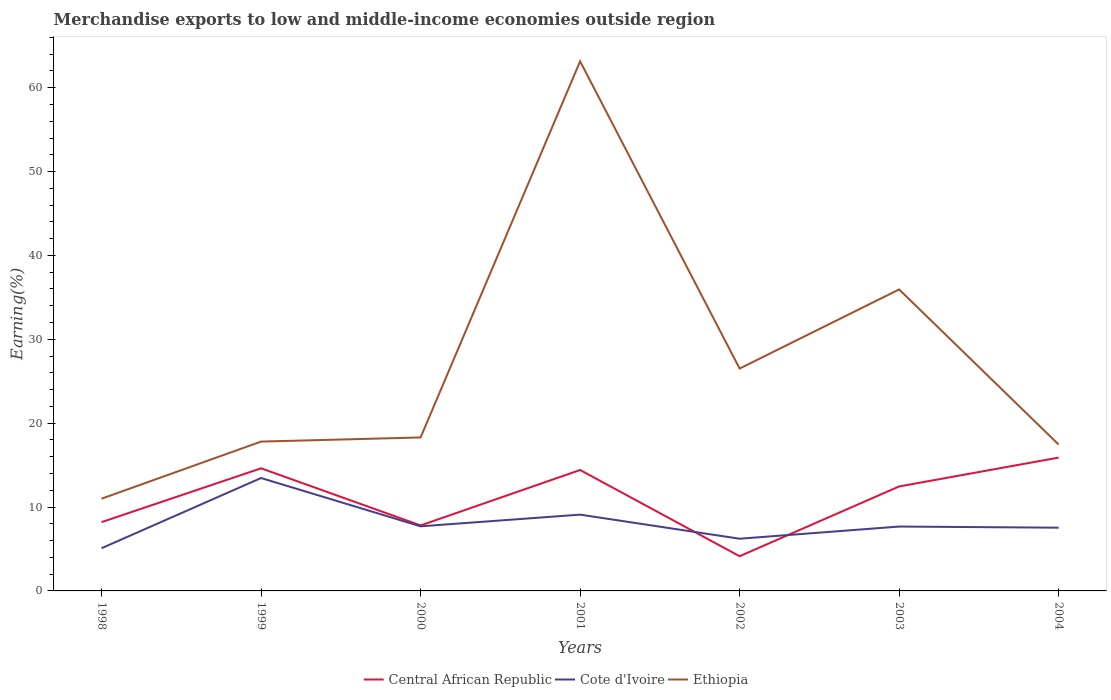How many different coloured lines are there?
Your answer should be compact. 3. Is the number of lines equal to the number of legend labels?
Provide a short and direct response. Yes. Across all years, what is the maximum percentage of amount earned from merchandise exports in Ethiopia?
Give a very brief answer. 11. In which year was the percentage of amount earned from merchandise exports in Central African Republic maximum?
Offer a terse response. 2002. What is the total percentage of amount earned from merchandise exports in Central African Republic in the graph?
Provide a short and direct response. -6.42. What is the difference between the highest and the second highest percentage of amount earned from merchandise exports in Central African Republic?
Ensure brevity in your answer.  11.76. How many lines are there?
Provide a short and direct response. 3. How many years are there in the graph?
Your answer should be very brief. 7. Where does the legend appear in the graph?
Provide a short and direct response. Bottom center. How many legend labels are there?
Offer a very short reply. 3. What is the title of the graph?
Offer a terse response. Merchandise exports to low and middle-income economies outside region. Does "Pacific island small states" appear as one of the legend labels in the graph?
Your answer should be very brief. No. What is the label or title of the Y-axis?
Provide a short and direct response. Earning(%). What is the Earning(%) of Central African Republic in 1998?
Provide a short and direct response. 8.2. What is the Earning(%) of Cote d'Ivoire in 1998?
Provide a succinct answer. 5.09. What is the Earning(%) of Ethiopia in 1998?
Your answer should be very brief. 11. What is the Earning(%) of Central African Republic in 1999?
Your answer should be very brief. 14.62. What is the Earning(%) in Cote d'Ivoire in 1999?
Make the answer very short. 13.46. What is the Earning(%) of Ethiopia in 1999?
Keep it short and to the point. 17.81. What is the Earning(%) of Central African Republic in 2000?
Offer a terse response. 7.81. What is the Earning(%) in Cote d'Ivoire in 2000?
Provide a succinct answer. 7.7. What is the Earning(%) of Ethiopia in 2000?
Offer a terse response. 18.3. What is the Earning(%) of Central African Republic in 2001?
Make the answer very short. 14.42. What is the Earning(%) in Cote d'Ivoire in 2001?
Your response must be concise. 9.1. What is the Earning(%) in Ethiopia in 2001?
Keep it short and to the point. 63.14. What is the Earning(%) of Central African Republic in 2002?
Offer a terse response. 4.14. What is the Earning(%) of Cote d'Ivoire in 2002?
Offer a very short reply. 6.22. What is the Earning(%) of Ethiopia in 2002?
Offer a terse response. 26.51. What is the Earning(%) in Central African Republic in 2003?
Your answer should be very brief. 12.46. What is the Earning(%) in Cote d'Ivoire in 2003?
Your answer should be very brief. 7.68. What is the Earning(%) in Ethiopia in 2003?
Offer a very short reply. 35.94. What is the Earning(%) of Central African Republic in 2004?
Offer a very short reply. 15.9. What is the Earning(%) in Cote d'Ivoire in 2004?
Give a very brief answer. 7.54. What is the Earning(%) of Ethiopia in 2004?
Your response must be concise. 17.45. Across all years, what is the maximum Earning(%) in Central African Republic?
Provide a short and direct response. 15.9. Across all years, what is the maximum Earning(%) of Cote d'Ivoire?
Give a very brief answer. 13.46. Across all years, what is the maximum Earning(%) in Ethiopia?
Offer a terse response. 63.14. Across all years, what is the minimum Earning(%) of Central African Republic?
Offer a very short reply. 4.14. Across all years, what is the minimum Earning(%) in Cote d'Ivoire?
Give a very brief answer. 5.09. Across all years, what is the minimum Earning(%) of Ethiopia?
Provide a succinct answer. 11. What is the total Earning(%) of Central African Republic in the graph?
Give a very brief answer. 77.54. What is the total Earning(%) of Cote d'Ivoire in the graph?
Provide a short and direct response. 56.79. What is the total Earning(%) in Ethiopia in the graph?
Offer a terse response. 190.15. What is the difference between the Earning(%) of Central African Republic in 1998 and that in 1999?
Offer a very short reply. -6.42. What is the difference between the Earning(%) in Cote d'Ivoire in 1998 and that in 1999?
Provide a succinct answer. -8.37. What is the difference between the Earning(%) of Ethiopia in 1998 and that in 1999?
Offer a very short reply. -6.81. What is the difference between the Earning(%) of Central African Republic in 1998 and that in 2000?
Ensure brevity in your answer.  0.39. What is the difference between the Earning(%) in Cote d'Ivoire in 1998 and that in 2000?
Give a very brief answer. -2.61. What is the difference between the Earning(%) of Ethiopia in 1998 and that in 2000?
Provide a succinct answer. -7.3. What is the difference between the Earning(%) in Central African Republic in 1998 and that in 2001?
Your answer should be very brief. -6.21. What is the difference between the Earning(%) in Cote d'Ivoire in 1998 and that in 2001?
Your response must be concise. -4. What is the difference between the Earning(%) of Ethiopia in 1998 and that in 2001?
Give a very brief answer. -52.15. What is the difference between the Earning(%) of Central African Republic in 1998 and that in 2002?
Offer a terse response. 4.07. What is the difference between the Earning(%) in Cote d'Ivoire in 1998 and that in 2002?
Make the answer very short. -1.13. What is the difference between the Earning(%) of Ethiopia in 1998 and that in 2002?
Provide a short and direct response. -15.51. What is the difference between the Earning(%) in Central African Republic in 1998 and that in 2003?
Your answer should be very brief. -4.25. What is the difference between the Earning(%) in Cote d'Ivoire in 1998 and that in 2003?
Your answer should be very brief. -2.58. What is the difference between the Earning(%) of Ethiopia in 1998 and that in 2003?
Offer a very short reply. -24.95. What is the difference between the Earning(%) of Central African Republic in 1998 and that in 2004?
Keep it short and to the point. -7.69. What is the difference between the Earning(%) in Cote d'Ivoire in 1998 and that in 2004?
Provide a succinct answer. -2.45. What is the difference between the Earning(%) in Ethiopia in 1998 and that in 2004?
Make the answer very short. -6.46. What is the difference between the Earning(%) in Central African Republic in 1999 and that in 2000?
Make the answer very short. 6.81. What is the difference between the Earning(%) of Cote d'Ivoire in 1999 and that in 2000?
Your response must be concise. 5.76. What is the difference between the Earning(%) of Ethiopia in 1999 and that in 2000?
Make the answer very short. -0.49. What is the difference between the Earning(%) of Central African Republic in 1999 and that in 2001?
Offer a terse response. 0.2. What is the difference between the Earning(%) of Cote d'Ivoire in 1999 and that in 2001?
Offer a terse response. 4.36. What is the difference between the Earning(%) of Ethiopia in 1999 and that in 2001?
Give a very brief answer. -45.34. What is the difference between the Earning(%) of Central African Republic in 1999 and that in 2002?
Your answer should be very brief. 10.48. What is the difference between the Earning(%) in Cote d'Ivoire in 1999 and that in 2002?
Provide a succinct answer. 7.24. What is the difference between the Earning(%) of Ethiopia in 1999 and that in 2002?
Make the answer very short. -8.7. What is the difference between the Earning(%) in Central African Republic in 1999 and that in 2003?
Provide a succinct answer. 2.16. What is the difference between the Earning(%) in Cote d'Ivoire in 1999 and that in 2003?
Your response must be concise. 5.79. What is the difference between the Earning(%) of Ethiopia in 1999 and that in 2003?
Ensure brevity in your answer.  -18.14. What is the difference between the Earning(%) in Central African Republic in 1999 and that in 2004?
Offer a terse response. -1.28. What is the difference between the Earning(%) of Cote d'Ivoire in 1999 and that in 2004?
Provide a succinct answer. 5.92. What is the difference between the Earning(%) of Ethiopia in 1999 and that in 2004?
Make the answer very short. 0.35. What is the difference between the Earning(%) of Central African Republic in 2000 and that in 2001?
Your answer should be compact. -6.61. What is the difference between the Earning(%) in Cote d'Ivoire in 2000 and that in 2001?
Provide a succinct answer. -1.39. What is the difference between the Earning(%) of Ethiopia in 2000 and that in 2001?
Provide a short and direct response. -44.85. What is the difference between the Earning(%) of Central African Republic in 2000 and that in 2002?
Ensure brevity in your answer.  3.67. What is the difference between the Earning(%) in Cote d'Ivoire in 2000 and that in 2002?
Ensure brevity in your answer.  1.48. What is the difference between the Earning(%) of Ethiopia in 2000 and that in 2002?
Your response must be concise. -8.21. What is the difference between the Earning(%) in Central African Republic in 2000 and that in 2003?
Offer a terse response. -4.65. What is the difference between the Earning(%) of Cote d'Ivoire in 2000 and that in 2003?
Your answer should be compact. 0.03. What is the difference between the Earning(%) of Ethiopia in 2000 and that in 2003?
Offer a terse response. -17.65. What is the difference between the Earning(%) of Central African Republic in 2000 and that in 2004?
Give a very brief answer. -8.09. What is the difference between the Earning(%) in Cote d'Ivoire in 2000 and that in 2004?
Offer a terse response. 0.16. What is the difference between the Earning(%) in Ethiopia in 2000 and that in 2004?
Keep it short and to the point. 0.85. What is the difference between the Earning(%) in Central African Republic in 2001 and that in 2002?
Your answer should be very brief. 10.28. What is the difference between the Earning(%) of Cote d'Ivoire in 2001 and that in 2002?
Your answer should be compact. 2.87. What is the difference between the Earning(%) in Ethiopia in 2001 and that in 2002?
Keep it short and to the point. 36.63. What is the difference between the Earning(%) of Central African Republic in 2001 and that in 2003?
Your response must be concise. 1.96. What is the difference between the Earning(%) of Cote d'Ivoire in 2001 and that in 2003?
Your response must be concise. 1.42. What is the difference between the Earning(%) of Ethiopia in 2001 and that in 2003?
Give a very brief answer. 27.2. What is the difference between the Earning(%) of Central African Republic in 2001 and that in 2004?
Your response must be concise. -1.48. What is the difference between the Earning(%) in Cote d'Ivoire in 2001 and that in 2004?
Your answer should be very brief. 1.56. What is the difference between the Earning(%) of Ethiopia in 2001 and that in 2004?
Keep it short and to the point. 45.69. What is the difference between the Earning(%) in Central African Republic in 2002 and that in 2003?
Your answer should be compact. -8.32. What is the difference between the Earning(%) in Cote d'Ivoire in 2002 and that in 2003?
Ensure brevity in your answer.  -1.45. What is the difference between the Earning(%) in Ethiopia in 2002 and that in 2003?
Your response must be concise. -9.43. What is the difference between the Earning(%) in Central African Republic in 2002 and that in 2004?
Offer a very short reply. -11.76. What is the difference between the Earning(%) of Cote d'Ivoire in 2002 and that in 2004?
Ensure brevity in your answer.  -1.32. What is the difference between the Earning(%) in Ethiopia in 2002 and that in 2004?
Keep it short and to the point. 9.06. What is the difference between the Earning(%) of Central African Republic in 2003 and that in 2004?
Provide a succinct answer. -3.44. What is the difference between the Earning(%) in Cote d'Ivoire in 2003 and that in 2004?
Make the answer very short. 0.14. What is the difference between the Earning(%) of Ethiopia in 2003 and that in 2004?
Your answer should be very brief. 18.49. What is the difference between the Earning(%) in Central African Republic in 1998 and the Earning(%) in Cote d'Ivoire in 1999?
Your answer should be very brief. -5.26. What is the difference between the Earning(%) of Central African Republic in 1998 and the Earning(%) of Ethiopia in 1999?
Provide a short and direct response. -9.6. What is the difference between the Earning(%) of Cote d'Ivoire in 1998 and the Earning(%) of Ethiopia in 1999?
Your answer should be compact. -12.71. What is the difference between the Earning(%) of Central African Republic in 1998 and the Earning(%) of Cote d'Ivoire in 2000?
Your response must be concise. 0.5. What is the difference between the Earning(%) in Central African Republic in 1998 and the Earning(%) in Ethiopia in 2000?
Provide a succinct answer. -10.1. What is the difference between the Earning(%) in Cote d'Ivoire in 1998 and the Earning(%) in Ethiopia in 2000?
Provide a short and direct response. -13.21. What is the difference between the Earning(%) in Central African Republic in 1998 and the Earning(%) in Cote d'Ivoire in 2001?
Provide a succinct answer. -0.89. What is the difference between the Earning(%) of Central African Republic in 1998 and the Earning(%) of Ethiopia in 2001?
Your response must be concise. -54.94. What is the difference between the Earning(%) of Cote d'Ivoire in 1998 and the Earning(%) of Ethiopia in 2001?
Ensure brevity in your answer.  -58.05. What is the difference between the Earning(%) in Central African Republic in 1998 and the Earning(%) in Cote d'Ivoire in 2002?
Your response must be concise. 1.98. What is the difference between the Earning(%) of Central African Republic in 1998 and the Earning(%) of Ethiopia in 2002?
Keep it short and to the point. -18.31. What is the difference between the Earning(%) in Cote d'Ivoire in 1998 and the Earning(%) in Ethiopia in 2002?
Ensure brevity in your answer.  -21.42. What is the difference between the Earning(%) in Central African Republic in 1998 and the Earning(%) in Cote d'Ivoire in 2003?
Make the answer very short. 0.53. What is the difference between the Earning(%) of Central African Republic in 1998 and the Earning(%) of Ethiopia in 2003?
Your response must be concise. -27.74. What is the difference between the Earning(%) of Cote d'Ivoire in 1998 and the Earning(%) of Ethiopia in 2003?
Your answer should be compact. -30.85. What is the difference between the Earning(%) in Central African Republic in 1998 and the Earning(%) in Cote d'Ivoire in 2004?
Keep it short and to the point. 0.66. What is the difference between the Earning(%) of Central African Republic in 1998 and the Earning(%) of Ethiopia in 2004?
Offer a very short reply. -9.25. What is the difference between the Earning(%) of Cote d'Ivoire in 1998 and the Earning(%) of Ethiopia in 2004?
Give a very brief answer. -12.36. What is the difference between the Earning(%) in Central African Republic in 1999 and the Earning(%) in Cote d'Ivoire in 2000?
Your answer should be very brief. 6.92. What is the difference between the Earning(%) in Central African Republic in 1999 and the Earning(%) in Ethiopia in 2000?
Ensure brevity in your answer.  -3.68. What is the difference between the Earning(%) of Cote d'Ivoire in 1999 and the Earning(%) of Ethiopia in 2000?
Offer a very short reply. -4.84. What is the difference between the Earning(%) in Central African Republic in 1999 and the Earning(%) in Cote d'Ivoire in 2001?
Make the answer very short. 5.52. What is the difference between the Earning(%) of Central African Republic in 1999 and the Earning(%) of Ethiopia in 2001?
Ensure brevity in your answer.  -48.52. What is the difference between the Earning(%) of Cote d'Ivoire in 1999 and the Earning(%) of Ethiopia in 2001?
Offer a very short reply. -49.68. What is the difference between the Earning(%) of Central African Republic in 1999 and the Earning(%) of Cote d'Ivoire in 2002?
Keep it short and to the point. 8.4. What is the difference between the Earning(%) in Central African Republic in 1999 and the Earning(%) in Ethiopia in 2002?
Your answer should be very brief. -11.89. What is the difference between the Earning(%) of Cote d'Ivoire in 1999 and the Earning(%) of Ethiopia in 2002?
Ensure brevity in your answer.  -13.05. What is the difference between the Earning(%) in Central African Republic in 1999 and the Earning(%) in Cote d'Ivoire in 2003?
Offer a very short reply. 6.94. What is the difference between the Earning(%) of Central African Republic in 1999 and the Earning(%) of Ethiopia in 2003?
Provide a short and direct response. -21.33. What is the difference between the Earning(%) of Cote d'Ivoire in 1999 and the Earning(%) of Ethiopia in 2003?
Your answer should be very brief. -22.48. What is the difference between the Earning(%) of Central African Republic in 1999 and the Earning(%) of Cote d'Ivoire in 2004?
Your response must be concise. 7.08. What is the difference between the Earning(%) in Central African Republic in 1999 and the Earning(%) in Ethiopia in 2004?
Offer a very short reply. -2.83. What is the difference between the Earning(%) of Cote d'Ivoire in 1999 and the Earning(%) of Ethiopia in 2004?
Your answer should be compact. -3.99. What is the difference between the Earning(%) of Central African Republic in 2000 and the Earning(%) of Cote d'Ivoire in 2001?
Offer a very short reply. -1.29. What is the difference between the Earning(%) in Central African Republic in 2000 and the Earning(%) in Ethiopia in 2001?
Provide a short and direct response. -55.34. What is the difference between the Earning(%) of Cote d'Ivoire in 2000 and the Earning(%) of Ethiopia in 2001?
Ensure brevity in your answer.  -55.44. What is the difference between the Earning(%) in Central African Republic in 2000 and the Earning(%) in Cote d'Ivoire in 2002?
Provide a short and direct response. 1.59. What is the difference between the Earning(%) of Central African Republic in 2000 and the Earning(%) of Ethiopia in 2002?
Provide a short and direct response. -18.7. What is the difference between the Earning(%) in Cote d'Ivoire in 2000 and the Earning(%) in Ethiopia in 2002?
Provide a short and direct response. -18.81. What is the difference between the Earning(%) of Central African Republic in 2000 and the Earning(%) of Cote d'Ivoire in 2003?
Make the answer very short. 0.13. What is the difference between the Earning(%) in Central African Republic in 2000 and the Earning(%) in Ethiopia in 2003?
Your answer should be very brief. -28.14. What is the difference between the Earning(%) in Cote d'Ivoire in 2000 and the Earning(%) in Ethiopia in 2003?
Your answer should be very brief. -28.24. What is the difference between the Earning(%) in Central African Republic in 2000 and the Earning(%) in Cote d'Ivoire in 2004?
Offer a very short reply. 0.27. What is the difference between the Earning(%) of Central African Republic in 2000 and the Earning(%) of Ethiopia in 2004?
Your answer should be compact. -9.64. What is the difference between the Earning(%) in Cote d'Ivoire in 2000 and the Earning(%) in Ethiopia in 2004?
Your answer should be very brief. -9.75. What is the difference between the Earning(%) of Central African Republic in 2001 and the Earning(%) of Cote d'Ivoire in 2002?
Your response must be concise. 8.19. What is the difference between the Earning(%) in Central African Republic in 2001 and the Earning(%) in Ethiopia in 2002?
Your answer should be compact. -12.09. What is the difference between the Earning(%) in Cote d'Ivoire in 2001 and the Earning(%) in Ethiopia in 2002?
Provide a short and direct response. -17.41. What is the difference between the Earning(%) of Central African Republic in 2001 and the Earning(%) of Cote d'Ivoire in 2003?
Ensure brevity in your answer.  6.74. What is the difference between the Earning(%) of Central African Republic in 2001 and the Earning(%) of Ethiopia in 2003?
Give a very brief answer. -21.53. What is the difference between the Earning(%) in Cote d'Ivoire in 2001 and the Earning(%) in Ethiopia in 2003?
Offer a terse response. -26.85. What is the difference between the Earning(%) in Central African Republic in 2001 and the Earning(%) in Cote d'Ivoire in 2004?
Ensure brevity in your answer.  6.88. What is the difference between the Earning(%) of Central African Republic in 2001 and the Earning(%) of Ethiopia in 2004?
Give a very brief answer. -3.04. What is the difference between the Earning(%) in Cote d'Ivoire in 2001 and the Earning(%) in Ethiopia in 2004?
Provide a short and direct response. -8.36. What is the difference between the Earning(%) in Central African Republic in 2002 and the Earning(%) in Cote d'Ivoire in 2003?
Keep it short and to the point. -3.54. What is the difference between the Earning(%) of Central African Republic in 2002 and the Earning(%) of Ethiopia in 2003?
Keep it short and to the point. -31.81. What is the difference between the Earning(%) of Cote d'Ivoire in 2002 and the Earning(%) of Ethiopia in 2003?
Provide a succinct answer. -29.72. What is the difference between the Earning(%) of Central African Republic in 2002 and the Earning(%) of Cote d'Ivoire in 2004?
Provide a short and direct response. -3.4. What is the difference between the Earning(%) in Central African Republic in 2002 and the Earning(%) in Ethiopia in 2004?
Offer a very short reply. -13.31. What is the difference between the Earning(%) in Cote d'Ivoire in 2002 and the Earning(%) in Ethiopia in 2004?
Your answer should be very brief. -11.23. What is the difference between the Earning(%) in Central African Republic in 2003 and the Earning(%) in Cote d'Ivoire in 2004?
Offer a terse response. 4.92. What is the difference between the Earning(%) in Central African Republic in 2003 and the Earning(%) in Ethiopia in 2004?
Your answer should be very brief. -5. What is the difference between the Earning(%) in Cote d'Ivoire in 2003 and the Earning(%) in Ethiopia in 2004?
Provide a succinct answer. -9.78. What is the average Earning(%) of Central African Republic per year?
Keep it short and to the point. 11.08. What is the average Earning(%) of Cote d'Ivoire per year?
Provide a short and direct response. 8.11. What is the average Earning(%) in Ethiopia per year?
Give a very brief answer. 27.16. In the year 1998, what is the difference between the Earning(%) in Central African Republic and Earning(%) in Cote d'Ivoire?
Offer a very short reply. 3.11. In the year 1998, what is the difference between the Earning(%) in Central African Republic and Earning(%) in Ethiopia?
Keep it short and to the point. -2.79. In the year 1998, what is the difference between the Earning(%) in Cote d'Ivoire and Earning(%) in Ethiopia?
Offer a very short reply. -5.9. In the year 1999, what is the difference between the Earning(%) of Central African Republic and Earning(%) of Cote d'Ivoire?
Your answer should be compact. 1.16. In the year 1999, what is the difference between the Earning(%) of Central African Republic and Earning(%) of Ethiopia?
Your answer should be compact. -3.19. In the year 1999, what is the difference between the Earning(%) of Cote d'Ivoire and Earning(%) of Ethiopia?
Ensure brevity in your answer.  -4.35. In the year 2000, what is the difference between the Earning(%) of Central African Republic and Earning(%) of Cote d'Ivoire?
Make the answer very short. 0.11. In the year 2000, what is the difference between the Earning(%) of Central African Republic and Earning(%) of Ethiopia?
Your answer should be compact. -10.49. In the year 2000, what is the difference between the Earning(%) of Cote d'Ivoire and Earning(%) of Ethiopia?
Provide a succinct answer. -10.6. In the year 2001, what is the difference between the Earning(%) in Central African Republic and Earning(%) in Cote d'Ivoire?
Make the answer very short. 5.32. In the year 2001, what is the difference between the Earning(%) in Central African Republic and Earning(%) in Ethiopia?
Provide a succinct answer. -48.73. In the year 2001, what is the difference between the Earning(%) of Cote d'Ivoire and Earning(%) of Ethiopia?
Ensure brevity in your answer.  -54.05. In the year 2002, what is the difference between the Earning(%) in Central African Republic and Earning(%) in Cote d'Ivoire?
Make the answer very short. -2.09. In the year 2002, what is the difference between the Earning(%) of Central African Republic and Earning(%) of Ethiopia?
Your response must be concise. -22.37. In the year 2002, what is the difference between the Earning(%) of Cote d'Ivoire and Earning(%) of Ethiopia?
Your response must be concise. -20.29. In the year 2003, what is the difference between the Earning(%) of Central African Republic and Earning(%) of Cote d'Ivoire?
Provide a short and direct response. 4.78. In the year 2003, what is the difference between the Earning(%) in Central African Republic and Earning(%) in Ethiopia?
Your answer should be very brief. -23.49. In the year 2003, what is the difference between the Earning(%) in Cote d'Ivoire and Earning(%) in Ethiopia?
Your answer should be compact. -28.27. In the year 2004, what is the difference between the Earning(%) in Central African Republic and Earning(%) in Cote d'Ivoire?
Your answer should be compact. 8.36. In the year 2004, what is the difference between the Earning(%) of Central African Republic and Earning(%) of Ethiopia?
Provide a short and direct response. -1.56. In the year 2004, what is the difference between the Earning(%) in Cote d'Ivoire and Earning(%) in Ethiopia?
Ensure brevity in your answer.  -9.91. What is the ratio of the Earning(%) in Central African Republic in 1998 to that in 1999?
Keep it short and to the point. 0.56. What is the ratio of the Earning(%) of Cote d'Ivoire in 1998 to that in 1999?
Your answer should be compact. 0.38. What is the ratio of the Earning(%) of Ethiopia in 1998 to that in 1999?
Offer a very short reply. 0.62. What is the ratio of the Earning(%) in Central African Republic in 1998 to that in 2000?
Offer a terse response. 1.05. What is the ratio of the Earning(%) of Cote d'Ivoire in 1998 to that in 2000?
Provide a short and direct response. 0.66. What is the ratio of the Earning(%) in Ethiopia in 1998 to that in 2000?
Give a very brief answer. 0.6. What is the ratio of the Earning(%) in Central African Republic in 1998 to that in 2001?
Your response must be concise. 0.57. What is the ratio of the Earning(%) of Cote d'Ivoire in 1998 to that in 2001?
Keep it short and to the point. 0.56. What is the ratio of the Earning(%) of Ethiopia in 1998 to that in 2001?
Your answer should be compact. 0.17. What is the ratio of the Earning(%) in Central African Republic in 1998 to that in 2002?
Give a very brief answer. 1.98. What is the ratio of the Earning(%) in Cote d'Ivoire in 1998 to that in 2002?
Provide a succinct answer. 0.82. What is the ratio of the Earning(%) in Ethiopia in 1998 to that in 2002?
Your response must be concise. 0.41. What is the ratio of the Earning(%) of Central African Republic in 1998 to that in 2003?
Give a very brief answer. 0.66. What is the ratio of the Earning(%) in Cote d'Ivoire in 1998 to that in 2003?
Provide a short and direct response. 0.66. What is the ratio of the Earning(%) of Ethiopia in 1998 to that in 2003?
Your answer should be compact. 0.31. What is the ratio of the Earning(%) in Central African Republic in 1998 to that in 2004?
Offer a terse response. 0.52. What is the ratio of the Earning(%) in Cote d'Ivoire in 1998 to that in 2004?
Your response must be concise. 0.68. What is the ratio of the Earning(%) of Ethiopia in 1998 to that in 2004?
Give a very brief answer. 0.63. What is the ratio of the Earning(%) in Central African Republic in 1999 to that in 2000?
Make the answer very short. 1.87. What is the ratio of the Earning(%) in Cote d'Ivoire in 1999 to that in 2000?
Your answer should be compact. 1.75. What is the ratio of the Earning(%) of Ethiopia in 1999 to that in 2000?
Your answer should be very brief. 0.97. What is the ratio of the Earning(%) in Cote d'Ivoire in 1999 to that in 2001?
Provide a succinct answer. 1.48. What is the ratio of the Earning(%) of Ethiopia in 1999 to that in 2001?
Your answer should be very brief. 0.28. What is the ratio of the Earning(%) in Central African Republic in 1999 to that in 2002?
Your answer should be compact. 3.53. What is the ratio of the Earning(%) in Cote d'Ivoire in 1999 to that in 2002?
Provide a short and direct response. 2.16. What is the ratio of the Earning(%) in Ethiopia in 1999 to that in 2002?
Keep it short and to the point. 0.67. What is the ratio of the Earning(%) in Central African Republic in 1999 to that in 2003?
Offer a terse response. 1.17. What is the ratio of the Earning(%) in Cote d'Ivoire in 1999 to that in 2003?
Offer a terse response. 1.75. What is the ratio of the Earning(%) in Ethiopia in 1999 to that in 2003?
Make the answer very short. 0.5. What is the ratio of the Earning(%) in Central African Republic in 1999 to that in 2004?
Provide a succinct answer. 0.92. What is the ratio of the Earning(%) of Cote d'Ivoire in 1999 to that in 2004?
Offer a terse response. 1.79. What is the ratio of the Earning(%) in Ethiopia in 1999 to that in 2004?
Your answer should be very brief. 1.02. What is the ratio of the Earning(%) of Central African Republic in 2000 to that in 2001?
Ensure brevity in your answer.  0.54. What is the ratio of the Earning(%) of Cote d'Ivoire in 2000 to that in 2001?
Your answer should be very brief. 0.85. What is the ratio of the Earning(%) in Ethiopia in 2000 to that in 2001?
Provide a short and direct response. 0.29. What is the ratio of the Earning(%) in Central African Republic in 2000 to that in 2002?
Your answer should be very brief. 1.89. What is the ratio of the Earning(%) in Cote d'Ivoire in 2000 to that in 2002?
Ensure brevity in your answer.  1.24. What is the ratio of the Earning(%) in Ethiopia in 2000 to that in 2002?
Offer a terse response. 0.69. What is the ratio of the Earning(%) of Central African Republic in 2000 to that in 2003?
Offer a very short reply. 0.63. What is the ratio of the Earning(%) in Cote d'Ivoire in 2000 to that in 2003?
Your answer should be compact. 1. What is the ratio of the Earning(%) of Ethiopia in 2000 to that in 2003?
Keep it short and to the point. 0.51. What is the ratio of the Earning(%) in Central African Republic in 2000 to that in 2004?
Ensure brevity in your answer.  0.49. What is the ratio of the Earning(%) in Cote d'Ivoire in 2000 to that in 2004?
Provide a succinct answer. 1.02. What is the ratio of the Earning(%) of Ethiopia in 2000 to that in 2004?
Your response must be concise. 1.05. What is the ratio of the Earning(%) in Central African Republic in 2001 to that in 2002?
Your answer should be compact. 3.48. What is the ratio of the Earning(%) in Cote d'Ivoire in 2001 to that in 2002?
Provide a short and direct response. 1.46. What is the ratio of the Earning(%) in Ethiopia in 2001 to that in 2002?
Provide a succinct answer. 2.38. What is the ratio of the Earning(%) in Central African Republic in 2001 to that in 2003?
Ensure brevity in your answer.  1.16. What is the ratio of the Earning(%) in Cote d'Ivoire in 2001 to that in 2003?
Give a very brief answer. 1.19. What is the ratio of the Earning(%) of Ethiopia in 2001 to that in 2003?
Offer a very short reply. 1.76. What is the ratio of the Earning(%) in Central African Republic in 2001 to that in 2004?
Your answer should be compact. 0.91. What is the ratio of the Earning(%) of Cote d'Ivoire in 2001 to that in 2004?
Make the answer very short. 1.21. What is the ratio of the Earning(%) in Ethiopia in 2001 to that in 2004?
Provide a succinct answer. 3.62. What is the ratio of the Earning(%) in Central African Republic in 2002 to that in 2003?
Keep it short and to the point. 0.33. What is the ratio of the Earning(%) in Cote d'Ivoire in 2002 to that in 2003?
Offer a very short reply. 0.81. What is the ratio of the Earning(%) in Ethiopia in 2002 to that in 2003?
Your answer should be compact. 0.74. What is the ratio of the Earning(%) in Central African Republic in 2002 to that in 2004?
Offer a very short reply. 0.26. What is the ratio of the Earning(%) in Cote d'Ivoire in 2002 to that in 2004?
Your answer should be compact. 0.83. What is the ratio of the Earning(%) in Ethiopia in 2002 to that in 2004?
Offer a very short reply. 1.52. What is the ratio of the Earning(%) of Central African Republic in 2003 to that in 2004?
Your answer should be compact. 0.78. What is the ratio of the Earning(%) in Cote d'Ivoire in 2003 to that in 2004?
Provide a short and direct response. 1.02. What is the ratio of the Earning(%) of Ethiopia in 2003 to that in 2004?
Offer a terse response. 2.06. What is the difference between the highest and the second highest Earning(%) of Central African Republic?
Your response must be concise. 1.28. What is the difference between the highest and the second highest Earning(%) of Cote d'Ivoire?
Your response must be concise. 4.36. What is the difference between the highest and the second highest Earning(%) of Ethiopia?
Your answer should be very brief. 27.2. What is the difference between the highest and the lowest Earning(%) in Central African Republic?
Offer a terse response. 11.76. What is the difference between the highest and the lowest Earning(%) of Cote d'Ivoire?
Give a very brief answer. 8.37. What is the difference between the highest and the lowest Earning(%) in Ethiopia?
Provide a short and direct response. 52.15. 